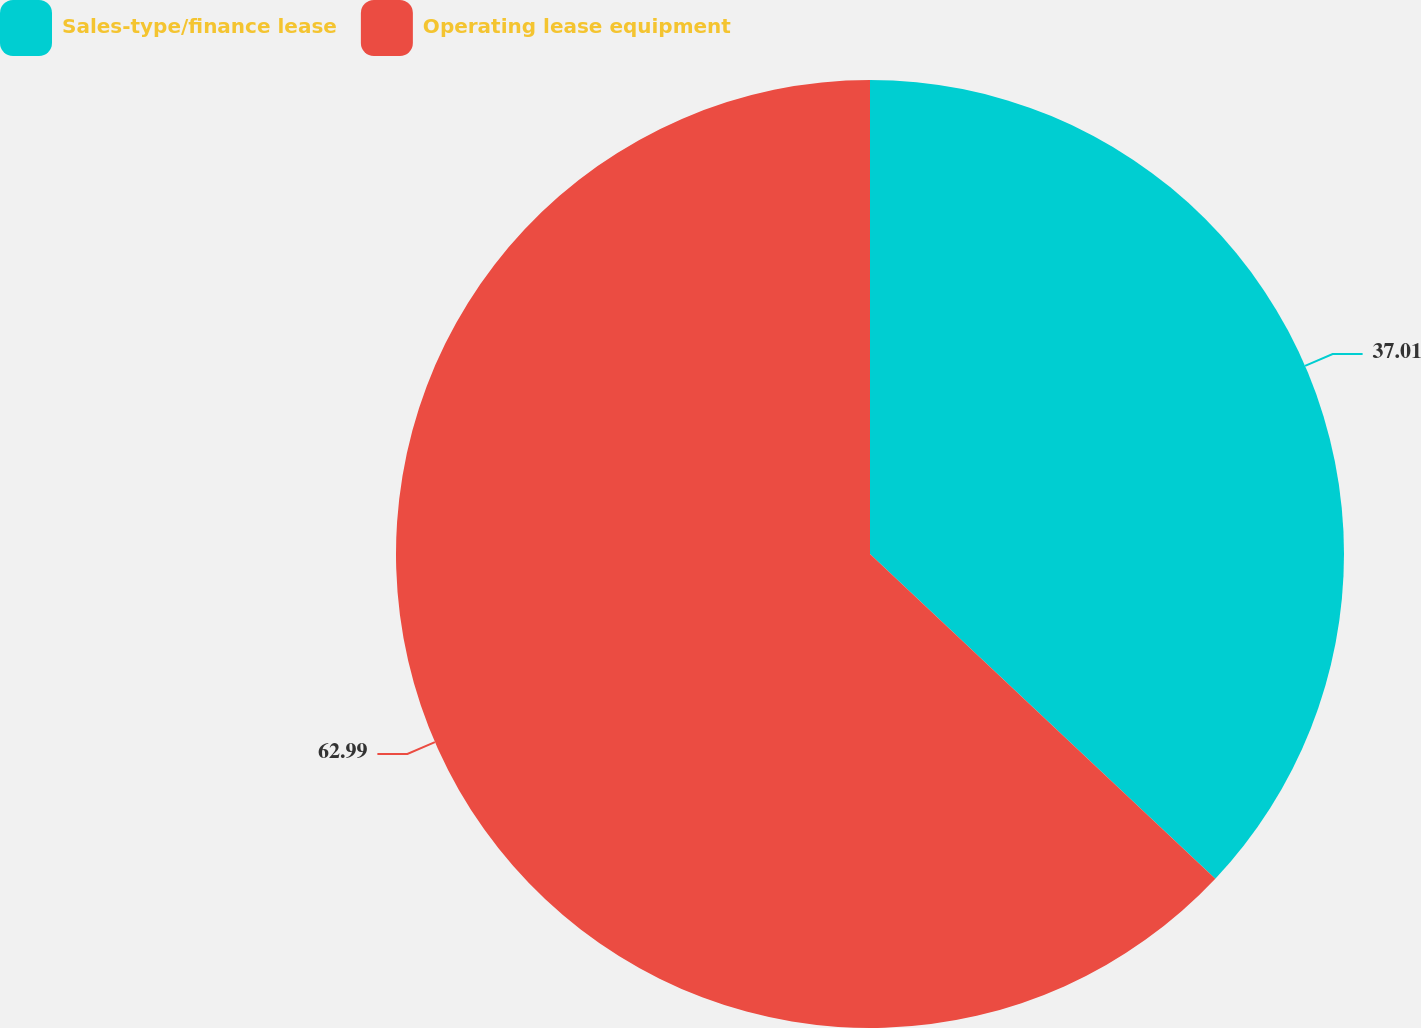<chart> <loc_0><loc_0><loc_500><loc_500><pie_chart><fcel>Sales-type/finance lease<fcel>Operating lease equipment<nl><fcel>37.01%<fcel>62.99%<nl></chart> 